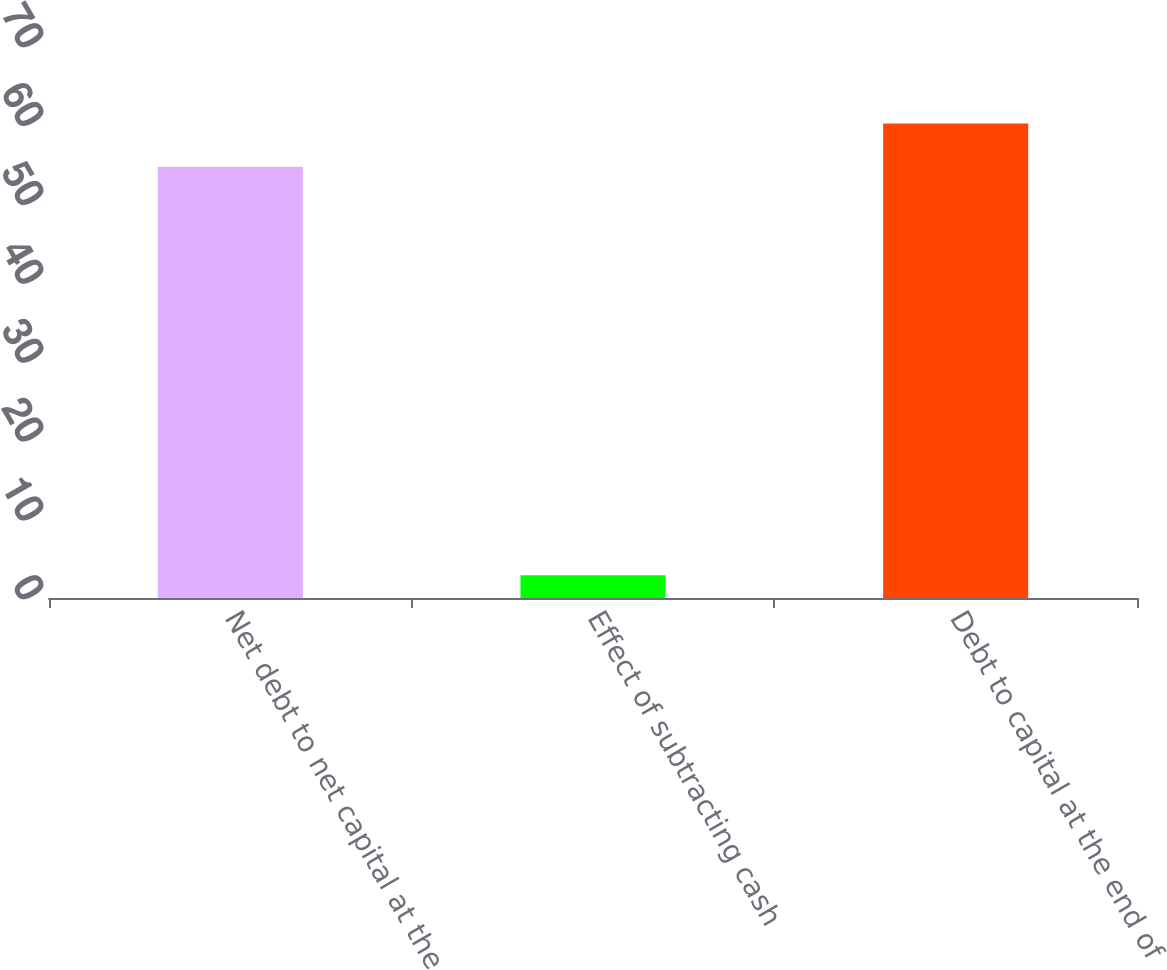Convert chart to OTSL. <chart><loc_0><loc_0><loc_500><loc_500><bar_chart><fcel>Net debt to net capital at the<fcel>Effect of subtracting cash<fcel>Debt to capital at the end of<nl><fcel>54.7<fcel>2.9<fcel>60.17<nl></chart> 